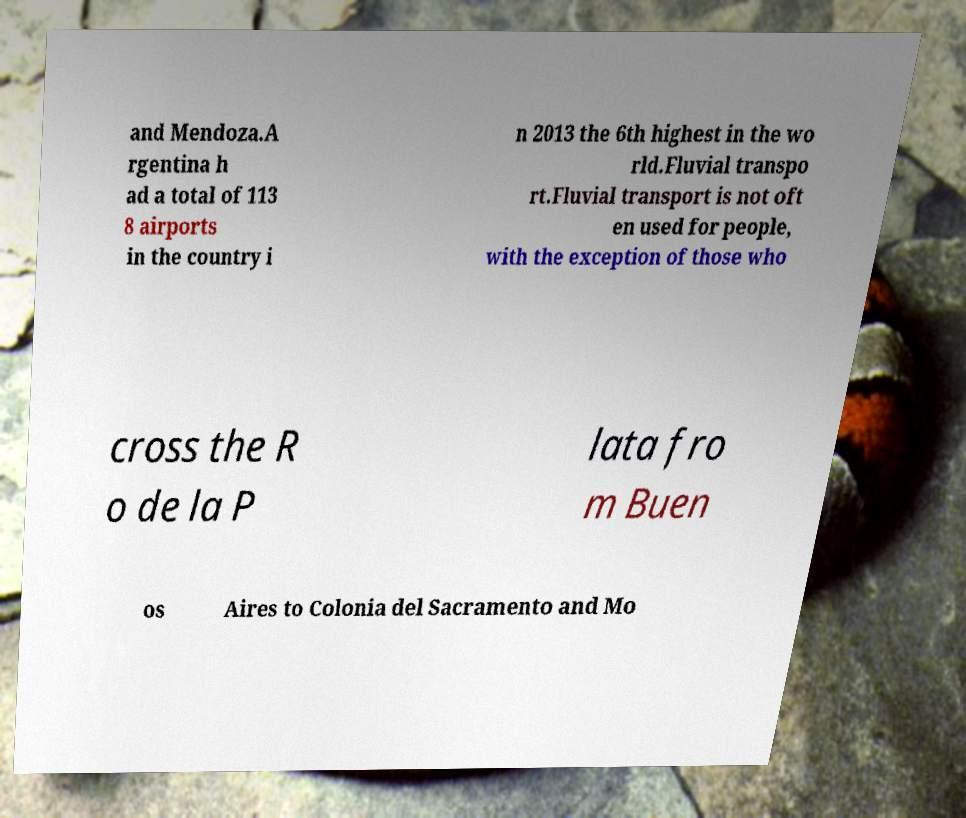What messages or text are displayed in this image? I need them in a readable, typed format. and Mendoza.A rgentina h ad a total of 113 8 airports in the country i n 2013 the 6th highest in the wo rld.Fluvial transpo rt.Fluvial transport is not oft en used for people, with the exception of those who cross the R o de la P lata fro m Buen os Aires to Colonia del Sacramento and Mo 